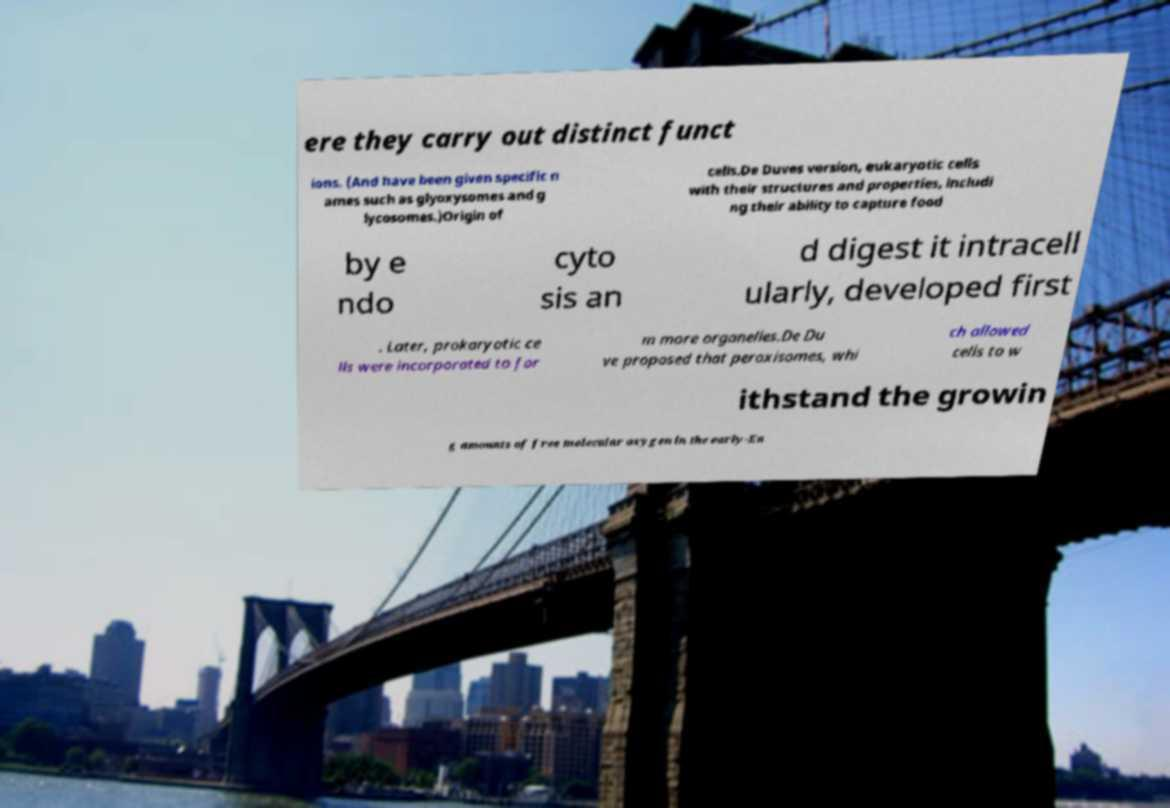Can you read and provide the text displayed in the image?This photo seems to have some interesting text. Can you extract and type it out for me? ere they carry out distinct funct ions. (And have been given specific n ames such as glyoxysomes and g lycosomes.)Origin of cells.De Duves version, eukaryotic cells with their structures and properties, includi ng their ability to capture food by e ndo cyto sis an d digest it intracell ularly, developed first . Later, prokaryotic ce lls were incorporated to for m more organelles.De Du ve proposed that peroxisomes, whi ch allowed cells to w ithstand the growin g amounts of free molecular oxygen in the early-Ea 